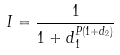Convert formula to latex. <formula><loc_0><loc_0><loc_500><loc_500>I = \frac { 1 } { 1 + d _ { 1 } ^ { P ( 1 + d _ { 2 } ) } }</formula> 